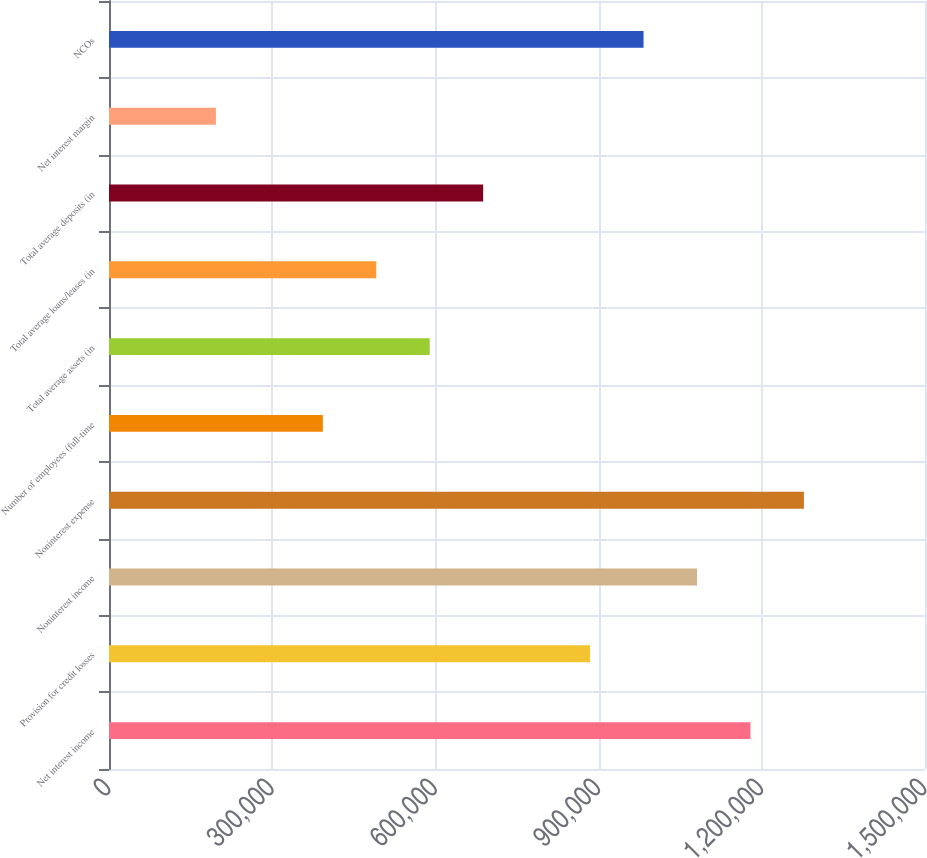<chart> <loc_0><loc_0><loc_500><loc_500><bar_chart><fcel>Net interest income<fcel>Provision for credit losses<fcel>Noninterest income<fcel>Noninterest expense<fcel>Number of employees (full-time<fcel>Total average assets (in<fcel>Total average loans/leases (in<fcel>Total average deposits (in<fcel>Net interest margin<fcel>NCOs<nl><fcel>1.17913e+06<fcel>884349<fcel>1.08087e+06<fcel>1.27739e+06<fcel>393045<fcel>589567<fcel>491306<fcel>687828<fcel>196524<fcel>982610<nl></chart> 